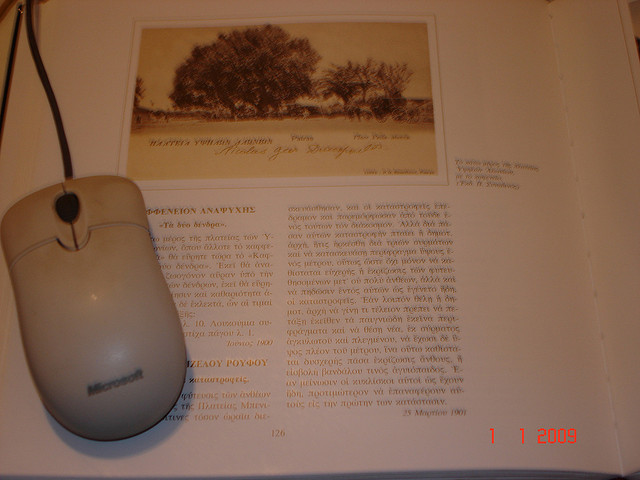Considering the modern context, could the juxtaposition of the mouse and the book symbolize the evolution of informational consumption? Absolutely, this juxtaposition reflects a transformative landscape in knowledge consumption. It highlights a transitional phase where digital devices such as the computer mouse are increasingly becoming integral to our reading habits, influencing how we interact with, interpret, and utilize information from traditional sources like books. 